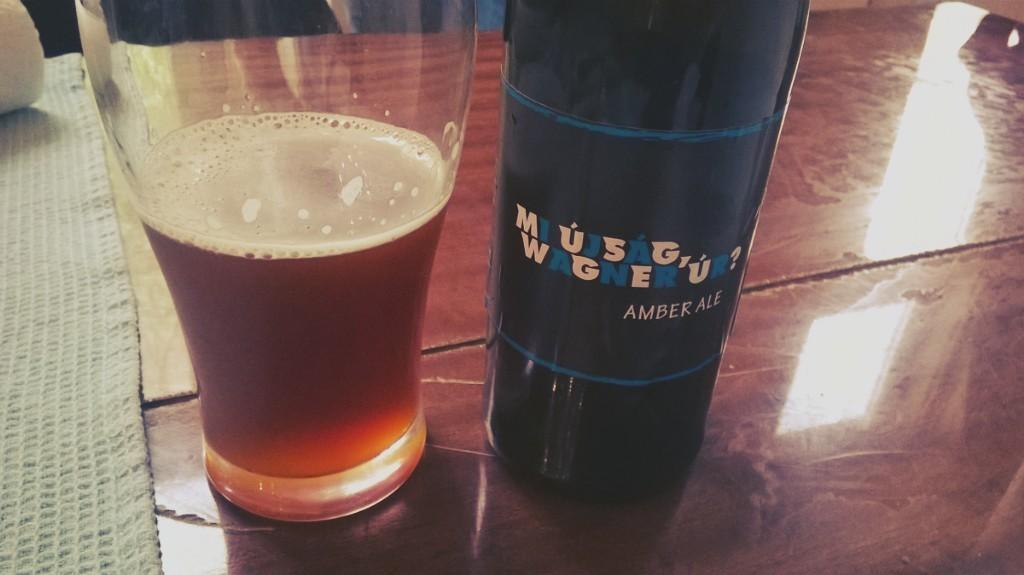<image>
Share a concise interpretation of the image provided. A bottle of amber ale next to what is presumably a glass of same. 